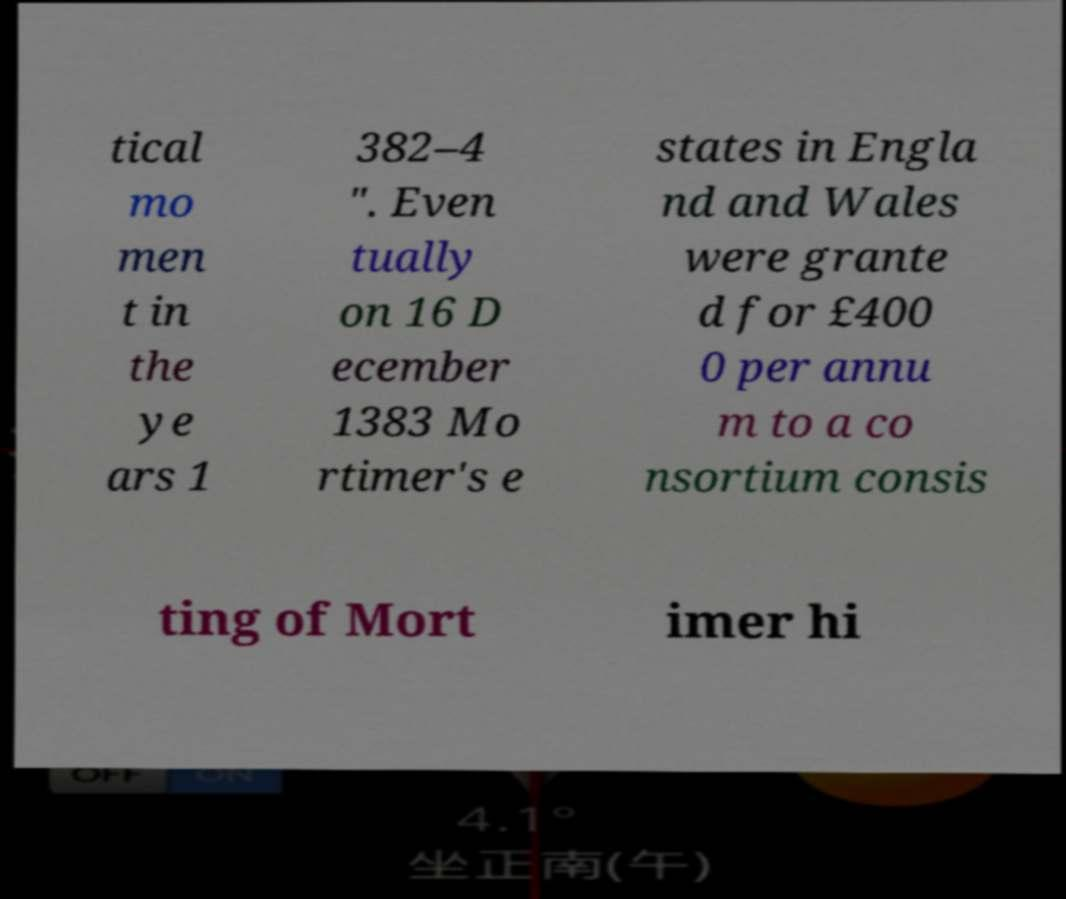Please identify and transcribe the text found in this image. tical mo men t in the ye ars 1 382–4 ". Even tually on 16 D ecember 1383 Mo rtimer's e states in Engla nd and Wales were grante d for £400 0 per annu m to a co nsortium consis ting of Mort imer hi 